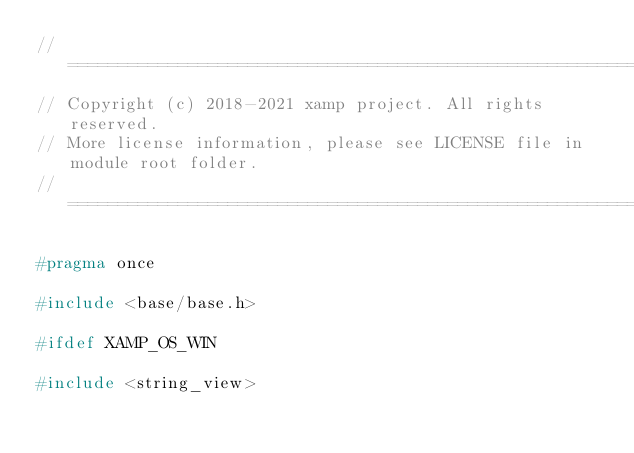Convert code to text. <code><loc_0><loc_0><loc_500><loc_500><_C_>//=====================================================================================================================
// Copyright (c) 2018-2021 xamp project. All rights reserved.
// More license information, please see LICENSE file in module root folder.
//=====================================================================================================================

#pragma once

#include <base/base.h>

#ifdef XAMP_OS_WIN

#include <string_view></code> 